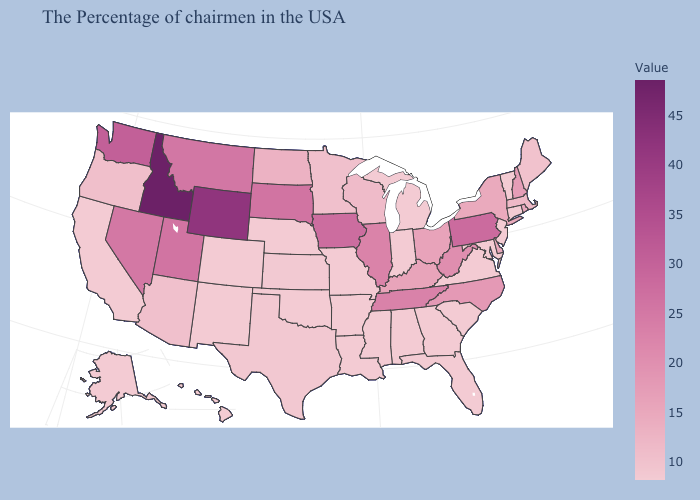Which states have the highest value in the USA?
Short answer required. Idaho. Among the states that border West Virginia , which have the lowest value?
Be succinct. Maryland, Virginia. Among the states that border Oregon , which have the lowest value?
Be succinct. California. Which states have the lowest value in the USA?
Keep it brief. Vermont, Connecticut, New Jersey, Maryland, Virginia, South Carolina, Florida, Georgia, Michigan, Indiana, Alabama, Mississippi, Louisiana, Missouri, Arkansas, Nebraska, Oklahoma, Colorado, New Mexico, California, Alaska, Hawaii. Does North Dakota have the lowest value in the MidWest?
Concise answer only. No. Does Idaho have the highest value in the USA?
Short answer required. Yes. 